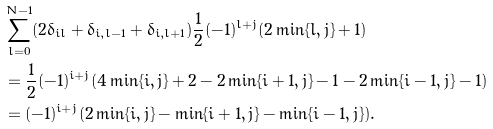<formula> <loc_0><loc_0><loc_500><loc_500>& \sum _ { l = 0 } ^ { N - 1 } ( 2 \delta _ { i l } + \delta _ { i , l - 1 } + \delta _ { i , l + 1 } ) \frac { 1 } { 2 } ( - 1 ) ^ { l + j } ( 2 \min \{ l , j \} + 1 ) \\ & = \frac { 1 } { 2 } ( - 1 ) ^ { i + j } ( 4 \min \{ i , j \} + 2 - 2 \min \{ i + 1 , j \} - 1 - 2 \min \{ i - 1 , j \} - 1 ) \\ & = ( - 1 ) ^ { i + j } ( 2 \min \{ i , j \} - \min \{ i + 1 , j \} - \min \{ i - 1 , j \} ) .</formula> 